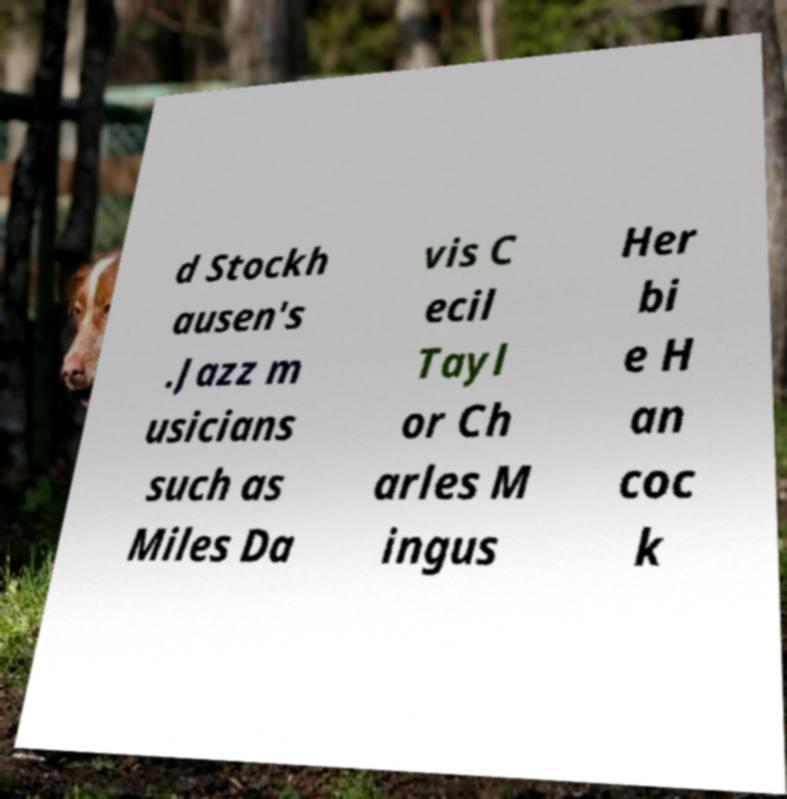Can you accurately transcribe the text from the provided image for me? d Stockh ausen's .Jazz m usicians such as Miles Da vis C ecil Tayl or Ch arles M ingus Her bi e H an coc k 